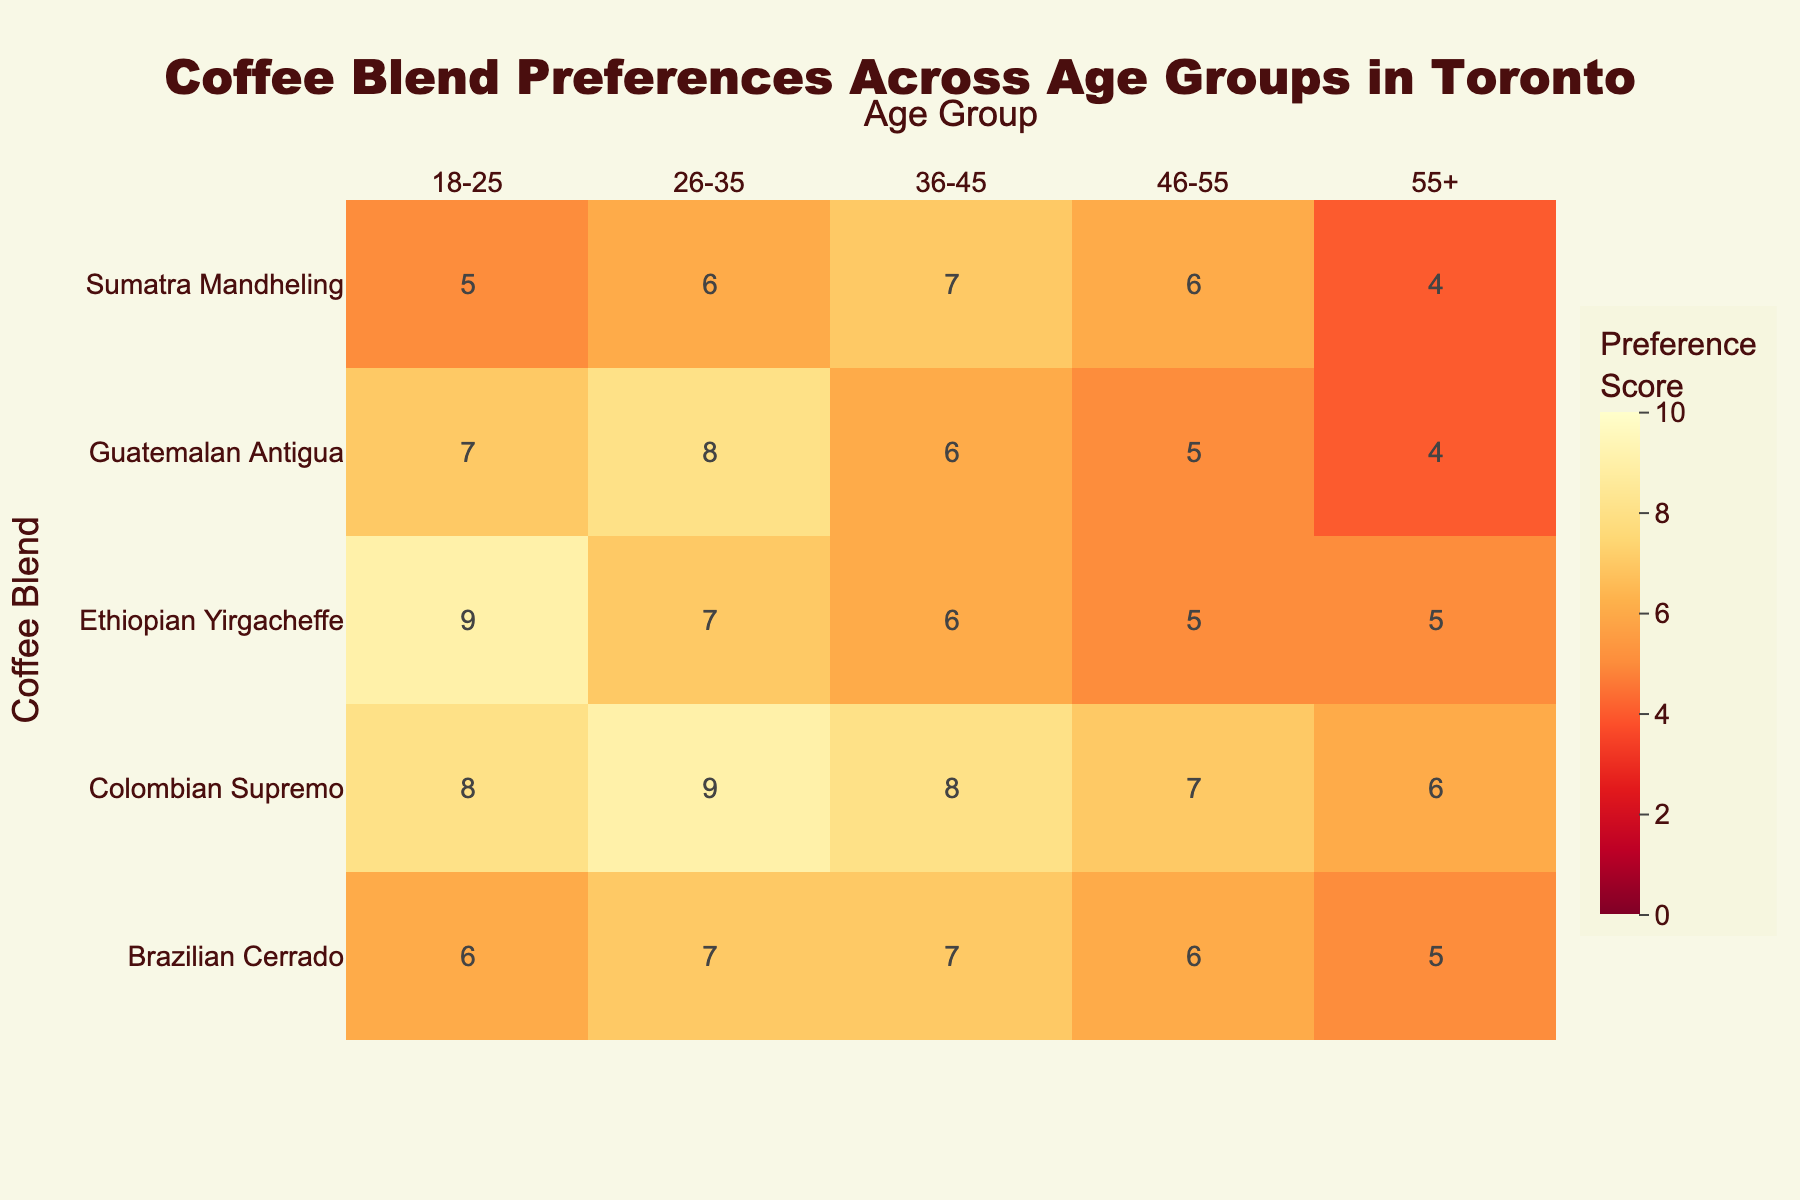What is the title of the figure? The title is typically placed at the top of the figure and provides a brief description of the displayed data.
Answer: Coffee Blend Preferences Across Age Groups in Toronto What age group has the highest preference score for Ethiopian Yirgacheffe? Look at the row corresponding to Ethiopian Yirgacheffe and find the column with the highest value.
Answer: 18-25 In which age group does Sumatra Mandheling have a preference score of 7? Identify the row corresponding to Sumatra Mandheling and locate the column where the preference score equals 7.
Answer: 36-45 Which coffee blend has the lowest preference score among customers aged 55+? Look for the minimum preference score in the column for age group 55+.
Answer: Guatemalan Antigua, Sumatra Mandheling Compare the preference score of Colombian Supremo between age groups 18-25 and 46-55. Which one is higher? Examine the preference scores of Colombian Supremo in the rows for age groups 18-25 and 46-55 and compare them.
Answer: 18-25 is higher Which age group has the least variation in preference scores for the different coffee blends? Assess the range (max - min) of scores within each age group and identify the smallest range.
Answer: 55+ How does the preference score of Ethiopian Yirgacheffe for age group 36-45 compare to that for age group 46-55? Compare the preference scores of Ethiopian Yirgacheffe for the age groups 36-45 and 46-55.
Answer: 36-45 is higher 